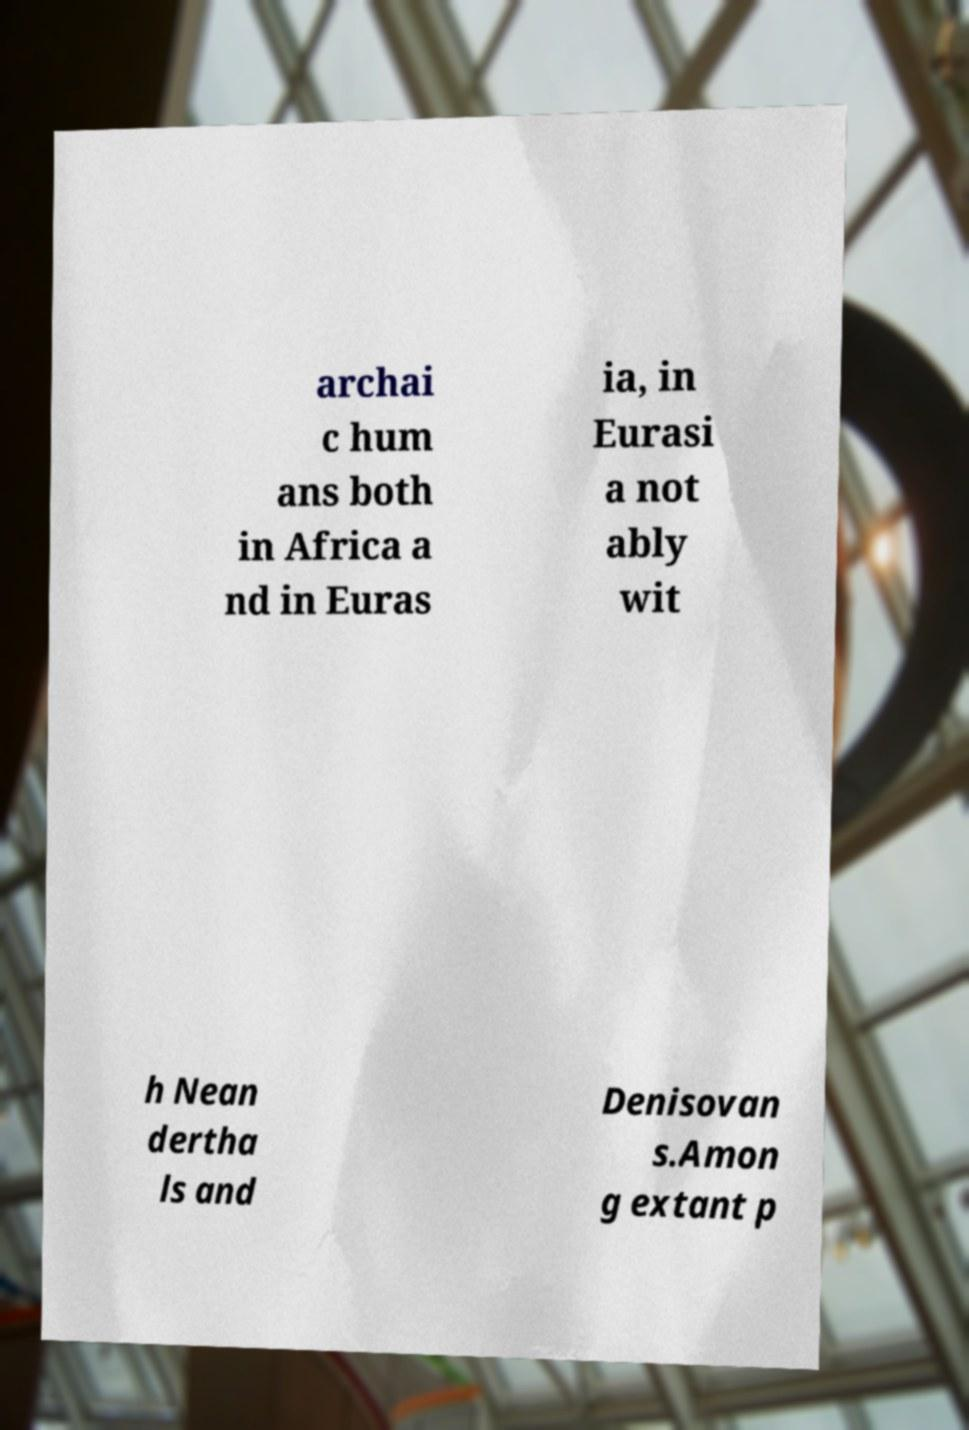I need the written content from this picture converted into text. Can you do that? archai c hum ans both in Africa a nd in Euras ia, in Eurasi a not ably wit h Nean dertha ls and Denisovan s.Amon g extant p 